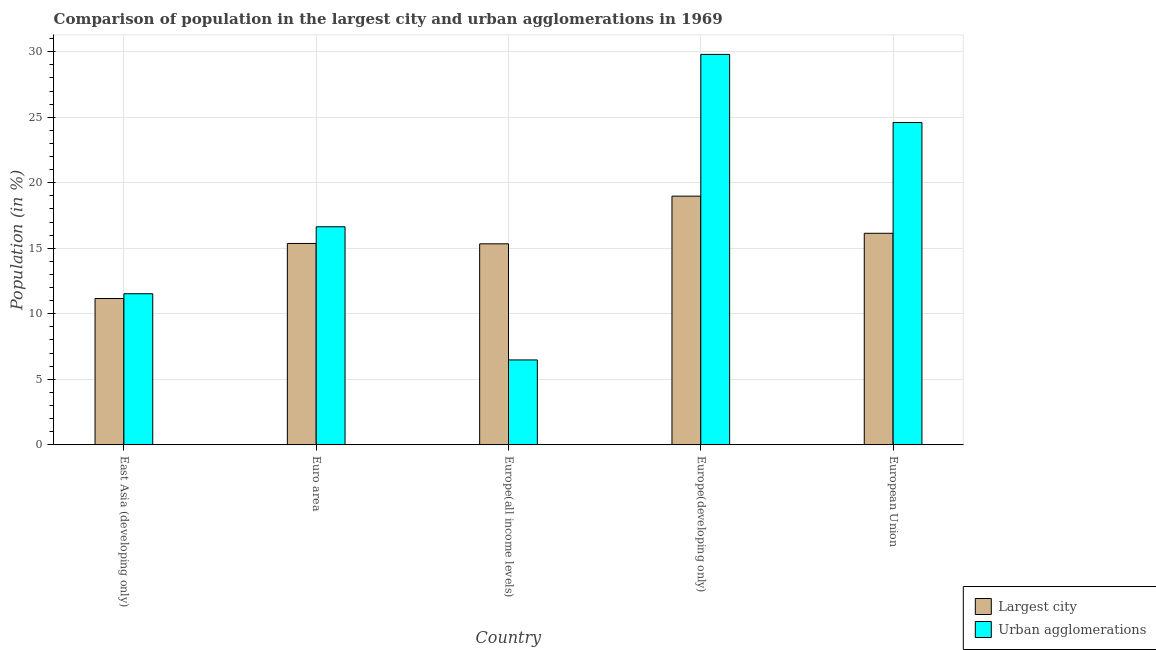What is the label of the 1st group of bars from the left?
Your answer should be very brief. East Asia (developing only). What is the population in the largest city in European Union?
Your response must be concise. 16.15. Across all countries, what is the maximum population in urban agglomerations?
Offer a very short reply. 29.8. Across all countries, what is the minimum population in the largest city?
Your response must be concise. 11.17. In which country was the population in the largest city maximum?
Make the answer very short. Europe(developing only). In which country was the population in the largest city minimum?
Give a very brief answer. East Asia (developing only). What is the total population in the largest city in the graph?
Give a very brief answer. 77.01. What is the difference between the population in the largest city in Europe(all income levels) and that in European Union?
Keep it short and to the point. -0.8. What is the difference between the population in urban agglomerations in Euro area and the population in the largest city in East Asia (developing only)?
Provide a short and direct response. 5.47. What is the average population in the largest city per country?
Provide a short and direct response. 15.4. What is the difference between the population in urban agglomerations and population in the largest city in Euro area?
Give a very brief answer. 1.27. What is the ratio of the population in the largest city in East Asia (developing only) to that in Europe(developing only)?
Provide a succinct answer. 0.59. Is the population in urban agglomerations in Europe(all income levels) less than that in Europe(developing only)?
Give a very brief answer. Yes. What is the difference between the highest and the second highest population in the largest city?
Your answer should be compact. 2.84. What is the difference between the highest and the lowest population in urban agglomerations?
Make the answer very short. 23.32. In how many countries, is the population in the largest city greater than the average population in the largest city taken over all countries?
Offer a terse response. 2. What does the 2nd bar from the left in Europe(all income levels) represents?
Your answer should be compact. Urban agglomerations. What does the 1st bar from the right in Euro area represents?
Provide a succinct answer. Urban agglomerations. How many countries are there in the graph?
Your answer should be compact. 5. What is the difference between two consecutive major ticks on the Y-axis?
Your answer should be very brief. 5. Does the graph contain any zero values?
Your answer should be compact. No. Where does the legend appear in the graph?
Your response must be concise. Bottom right. What is the title of the graph?
Ensure brevity in your answer.  Comparison of population in the largest city and urban agglomerations in 1969. Does "Gasoline" appear as one of the legend labels in the graph?
Offer a terse response. No. What is the Population (in %) in Largest city in East Asia (developing only)?
Your response must be concise. 11.17. What is the Population (in %) in Urban agglomerations in East Asia (developing only)?
Provide a short and direct response. 11.53. What is the Population (in %) in Largest city in Euro area?
Ensure brevity in your answer.  15.37. What is the Population (in %) of Urban agglomerations in Euro area?
Ensure brevity in your answer.  16.64. What is the Population (in %) of Largest city in Europe(all income levels)?
Your answer should be compact. 15.34. What is the Population (in %) of Urban agglomerations in Europe(all income levels)?
Provide a short and direct response. 6.48. What is the Population (in %) in Largest city in Europe(developing only)?
Provide a succinct answer. 18.98. What is the Population (in %) of Urban agglomerations in Europe(developing only)?
Offer a terse response. 29.8. What is the Population (in %) of Largest city in European Union?
Your answer should be very brief. 16.15. What is the Population (in %) of Urban agglomerations in European Union?
Ensure brevity in your answer.  24.6. Across all countries, what is the maximum Population (in %) in Largest city?
Provide a short and direct response. 18.98. Across all countries, what is the maximum Population (in %) of Urban agglomerations?
Offer a terse response. 29.8. Across all countries, what is the minimum Population (in %) in Largest city?
Provide a short and direct response. 11.17. Across all countries, what is the minimum Population (in %) of Urban agglomerations?
Your answer should be very brief. 6.48. What is the total Population (in %) of Largest city in the graph?
Give a very brief answer. 77.01. What is the total Population (in %) of Urban agglomerations in the graph?
Offer a terse response. 89.05. What is the difference between the Population (in %) of Largest city in East Asia (developing only) and that in Euro area?
Ensure brevity in your answer.  -4.2. What is the difference between the Population (in %) in Urban agglomerations in East Asia (developing only) and that in Euro area?
Keep it short and to the point. -5.11. What is the difference between the Population (in %) in Largest city in East Asia (developing only) and that in Europe(all income levels)?
Keep it short and to the point. -4.17. What is the difference between the Population (in %) in Urban agglomerations in East Asia (developing only) and that in Europe(all income levels)?
Provide a short and direct response. 5.05. What is the difference between the Population (in %) in Largest city in East Asia (developing only) and that in Europe(developing only)?
Make the answer very short. -7.81. What is the difference between the Population (in %) of Urban agglomerations in East Asia (developing only) and that in Europe(developing only)?
Your response must be concise. -18.27. What is the difference between the Population (in %) of Largest city in East Asia (developing only) and that in European Union?
Your answer should be very brief. -4.98. What is the difference between the Population (in %) of Urban agglomerations in East Asia (developing only) and that in European Union?
Provide a short and direct response. -13.07. What is the difference between the Population (in %) of Largest city in Euro area and that in Europe(all income levels)?
Offer a terse response. 0.03. What is the difference between the Population (in %) in Urban agglomerations in Euro area and that in Europe(all income levels)?
Your response must be concise. 10.16. What is the difference between the Population (in %) in Largest city in Euro area and that in Europe(developing only)?
Offer a very short reply. -3.61. What is the difference between the Population (in %) in Urban agglomerations in Euro area and that in Europe(developing only)?
Ensure brevity in your answer.  -13.16. What is the difference between the Population (in %) of Largest city in Euro area and that in European Union?
Offer a terse response. -0.78. What is the difference between the Population (in %) in Urban agglomerations in Euro area and that in European Union?
Offer a very short reply. -7.96. What is the difference between the Population (in %) in Largest city in Europe(all income levels) and that in Europe(developing only)?
Ensure brevity in your answer.  -3.64. What is the difference between the Population (in %) of Urban agglomerations in Europe(all income levels) and that in Europe(developing only)?
Your answer should be compact. -23.32. What is the difference between the Population (in %) in Largest city in Europe(all income levels) and that in European Union?
Provide a succinct answer. -0.8. What is the difference between the Population (in %) of Urban agglomerations in Europe(all income levels) and that in European Union?
Give a very brief answer. -18.12. What is the difference between the Population (in %) in Largest city in Europe(developing only) and that in European Union?
Provide a succinct answer. 2.84. What is the difference between the Population (in %) in Urban agglomerations in Europe(developing only) and that in European Union?
Provide a short and direct response. 5.2. What is the difference between the Population (in %) in Largest city in East Asia (developing only) and the Population (in %) in Urban agglomerations in Euro area?
Provide a succinct answer. -5.47. What is the difference between the Population (in %) of Largest city in East Asia (developing only) and the Population (in %) of Urban agglomerations in Europe(all income levels)?
Your answer should be compact. 4.69. What is the difference between the Population (in %) of Largest city in East Asia (developing only) and the Population (in %) of Urban agglomerations in Europe(developing only)?
Offer a very short reply. -18.63. What is the difference between the Population (in %) in Largest city in East Asia (developing only) and the Population (in %) in Urban agglomerations in European Union?
Give a very brief answer. -13.43. What is the difference between the Population (in %) in Largest city in Euro area and the Population (in %) in Urban agglomerations in Europe(all income levels)?
Make the answer very short. 8.89. What is the difference between the Population (in %) in Largest city in Euro area and the Population (in %) in Urban agglomerations in Europe(developing only)?
Ensure brevity in your answer.  -14.43. What is the difference between the Population (in %) of Largest city in Euro area and the Population (in %) of Urban agglomerations in European Union?
Provide a succinct answer. -9.23. What is the difference between the Population (in %) in Largest city in Europe(all income levels) and the Population (in %) in Urban agglomerations in Europe(developing only)?
Give a very brief answer. -14.46. What is the difference between the Population (in %) in Largest city in Europe(all income levels) and the Population (in %) in Urban agglomerations in European Union?
Offer a very short reply. -9.26. What is the difference between the Population (in %) of Largest city in Europe(developing only) and the Population (in %) of Urban agglomerations in European Union?
Give a very brief answer. -5.62. What is the average Population (in %) in Largest city per country?
Keep it short and to the point. 15.4. What is the average Population (in %) in Urban agglomerations per country?
Your answer should be very brief. 17.81. What is the difference between the Population (in %) in Largest city and Population (in %) in Urban agglomerations in East Asia (developing only)?
Make the answer very short. -0.36. What is the difference between the Population (in %) in Largest city and Population (in %) in Urban agglomerations in Euro area?
Offer a terse response. -1.27. What is the difference between the Population (in %) in Largest city and Population (in %) in Urban agglomerations in Europe(all income levels)?
Make the answer very short. 8.86. What is the difference between the Population (in %) of Largest city and Population (in %) of Urban agglomerations in Europe(developing only)?
Make the answer very short. -10.82. What is the difference between the Population (in %) of Largest city and Population (in %) of Urban agglomerations in European Union?
Make the answer very short. -8.45. What is the ratio of the Population (in %) in Largest city in East Asia (developing only) to that in Euro area?
Provide a short and direct response. 0.73. What is the ratio of the Population (in %) of Urban agglomerations in East Asia (developing only) to that in Euro area?
Provide a succinct answer. 0.69. What is the ratio of the Population (in %) of Largest city in East Asia (developing only) to that in Europe(all income levels)?
Keep it short and to the point. 0.73. What is the ratio of the Population (in %) in Urban agglomerations in East Asia (developing only) to that in Europe(all income levels)?
Your response must be concise. 1.78. What is the ratio of the Population (in %) in Largest city in East Asia (developing only) to that in Europe(developing only)?
Make the answer very short. 0.59. What is the ratio of the Population (in %) in Urban agglomerations in East Asia (developing only) to that in Europe(developing only)?
Make the answer very short. 0.39. What is the ratio of the Population (in %) of Largest city in East Asia (developing only) to that in European Union?
Your answer should be compact. 0.69. What is the ratio of the Population (in %) in Urban agglomerations in East Asia (developing only) to that in European Union?
Keep it short and to the point. 0.47. What is the ratio of the Population (in %) in Urban agglomerations in Euro area to that in Europe(all income levels)?
Make the answer very short. 2.57. What is the ratio of the Population (in %) of Largest city in Euro area to that in Europe(developing only)?
Your response must be concise. 0.81. What is the ratio of the Population (in %) in Urban agglomerations in Euro area to that in Europe(developing only)?
Offer a very short reply. 0.56. What is the ratio of the Population (in %) in Largest city in Euro area to that in European Union?
Make the answer very short. 0.95. What is the ratio of the Population (in %) of Urban agglomerations in Euro area to that in European Union?
Keep it short and to the point. 0.68. What is the ratio of the Population (in %) in Largest city in Europe(all income levels) to that in Europe(developing only)?
Offer a very short reply. 0.81. What is the ratio of the Population (in %) in Urban agglomerations in Europe(all income levels) to that in Europe(developing only)?
Provide a succinct answer. 0.22. What is the ratio of the Population (in %) in Largest city in Europe(all income levels) to that in European Union?
Offer a terse response. 0.95. What is the ratio of the Population (in %) in Urban agglomerations in Europe(all income levels) to that in European Union?
Make the answer very short. 0.26. What is the ratio of the Population (in %) of Largest city in Europe(developing only) to that in European Union?
Offer a very short reply. 1.18. What is the ratio of the Population (in %) of Urban agglomerations in Europe(developing only) to that in European Union?
Make the answer very short. 1.21. What is the difference between the highest and the second highest Population (in %) in Largest city?
Give a very brief answer. 2.84. What is the difference between the highest and the second highest Population (in %) of Urban agglomerations?
Provide a succinct answer. 5.2. What is the difference between the highest and the lowest Population (in %) of Largest city?
Keep it short and to the point. 7.81. What is the difference between the highest and the lowest Population (in %) in Urban agglomerations?
Ensure brevity in your answer.  23.32. 